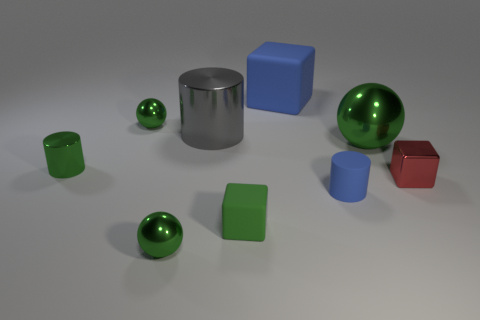Subtract all green balls. How many were subtracted if there are1green balls left? 2 Subtract all small rubber blocks. How many blocks are left? 2 Subtract all blue blocks. How many blocks are left? 2 Subtract 1 spheres. How many spheres are left? 2 Subtract all spheres. How many objects are left? 6 Subtract all tiny gray metal objects. Subtract all big rubber cubes. How many objects are left? 8 Add 4 balls. How many balls are left? 7 Add 6 blue things. How many blue things exist? 8 Subtract 3 green balls. How many objects are left? 6 Subtract all gray balls. Subtract all cyan blocks. How many balls are left? 3 